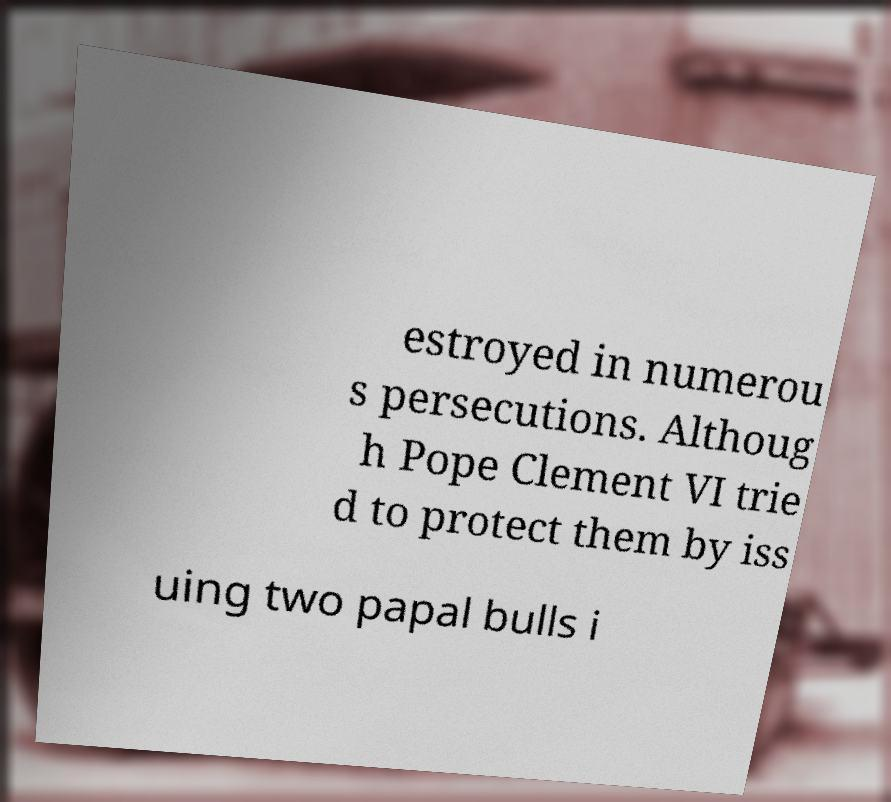What messages or text are displayed in this image? I need them in a readable, typed format. estroyed in numerou s persecutions. Althoug h Pope Clement VI trie d to protect them by iss uing two papal bulls i 